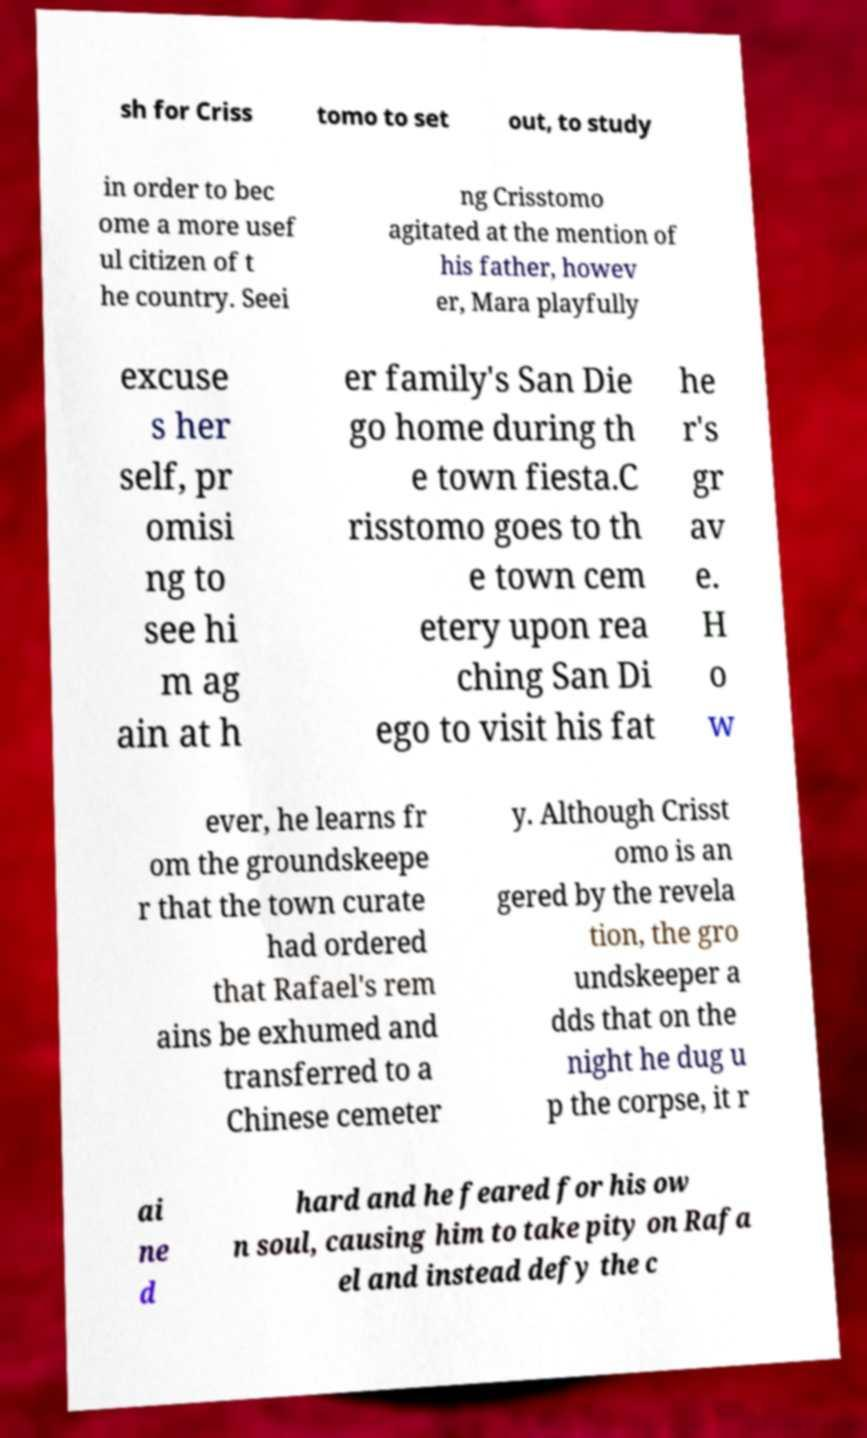Can you accurately transcribe the text from the provided image for me? sh for Criss tomo to set out, to study in order to bec ome a more usef ul citizen of t he country. Seei ng Crisstomo agitated at the mention of his father, howev er, Mara playfully excuse s her self, pr omisi ng to see hi m ag ain at h er family's San Die go home during th e town fiesta.C risstomo goes to th e town cem etery upon rea ching San Di ego to visit his fat he r's gr av e. H o w ever, he learns fr om the groundskeepe r that the town curate had ordered that Rafael's rem ains be exhumed and transferred to a Chinese cemeter y. Although Crisst omo is an gered by the revela tion, the gro undskeeper a dds that on the night he dug u p the corpse, it r ai ne d hard and he feared for his ow n soul, causing him to take pity on Rafa el and instead defy the c 